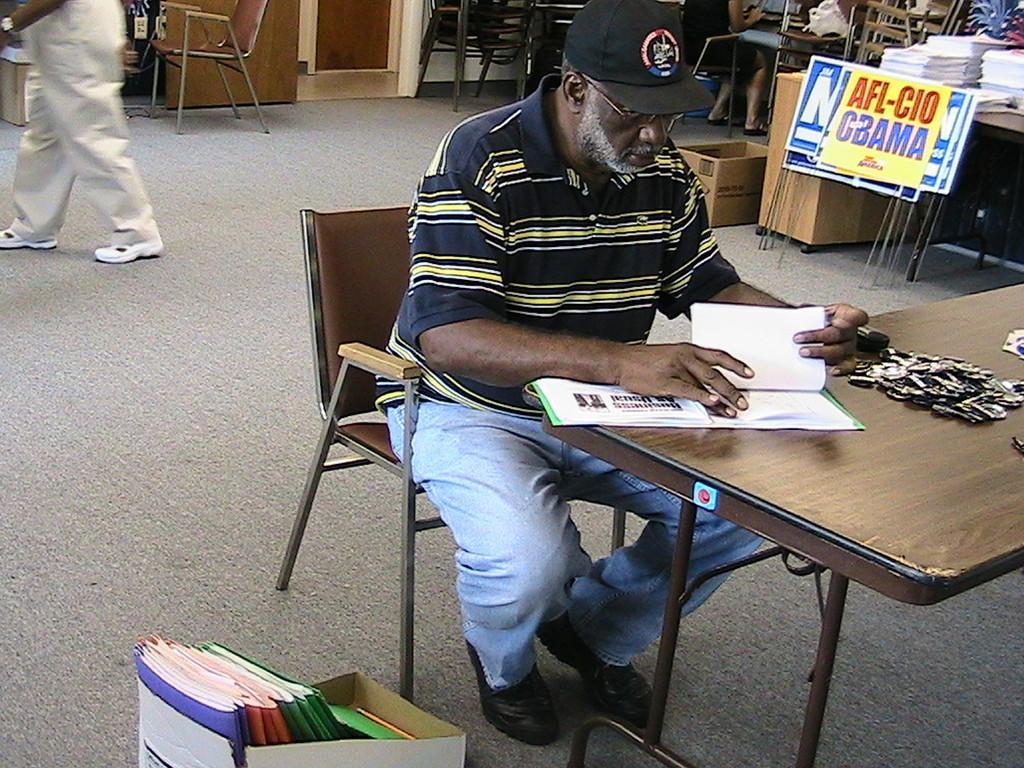Can you describe this image briefly? In this image I can see a person sitting on the chair and wearing cap. In front of him there is a book on the table. To the right of him there are some files in the card board box. At the back one person is walking. At the right there is a sign board and one person is sitting on the chair. There are some books on the table. 